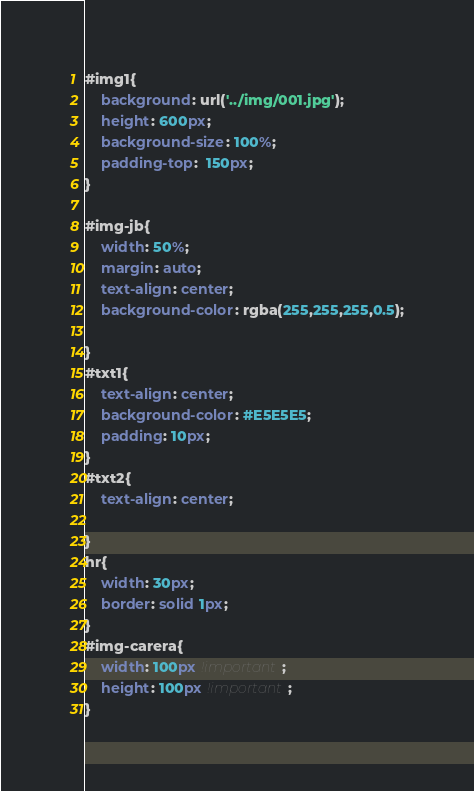Convert code to text. <code><loc_0><loc_0><loc_500><loc_500><_CSS_>#img1{
	background: url('../img/001.jpg');
	height: 600px;
	background-size: 100%;
	padding-top:  150px;
}

#img-jb{
	width: 50%;
	margin: auto;
	text-align: center;
	background-color: rgba(255,255,255,0.5);

}
#txt1{
	text-align: center;
	background-color: #E5E5E5;
	padding: 10px;
}
#txt2{
	text-align: center;

}
hr{
	width: 30px;
	border: solid 1px;
}
#img-carera{
	width: 100px !important;
	height: 100px !important;
}</code> 